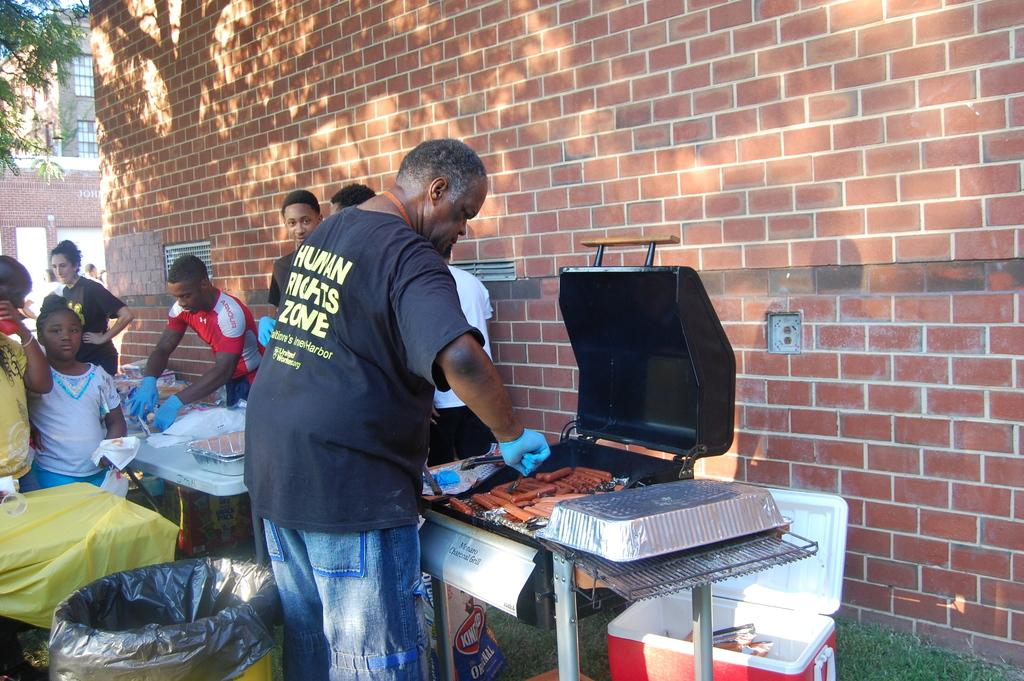Provide a one-sentence caption for the provided image. a man grilling hotdogs while wearing a HUman Rights Zone t-shirt. 